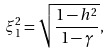Convert formula to latex. <formula><loc_0><loc_0><loc_500><loc_500>\xi _ { 1 } ^ { 2 } = \sqrt { \frac { 1 - h ^ { 2 } } { 1 - \gamma } } ,</formula> 